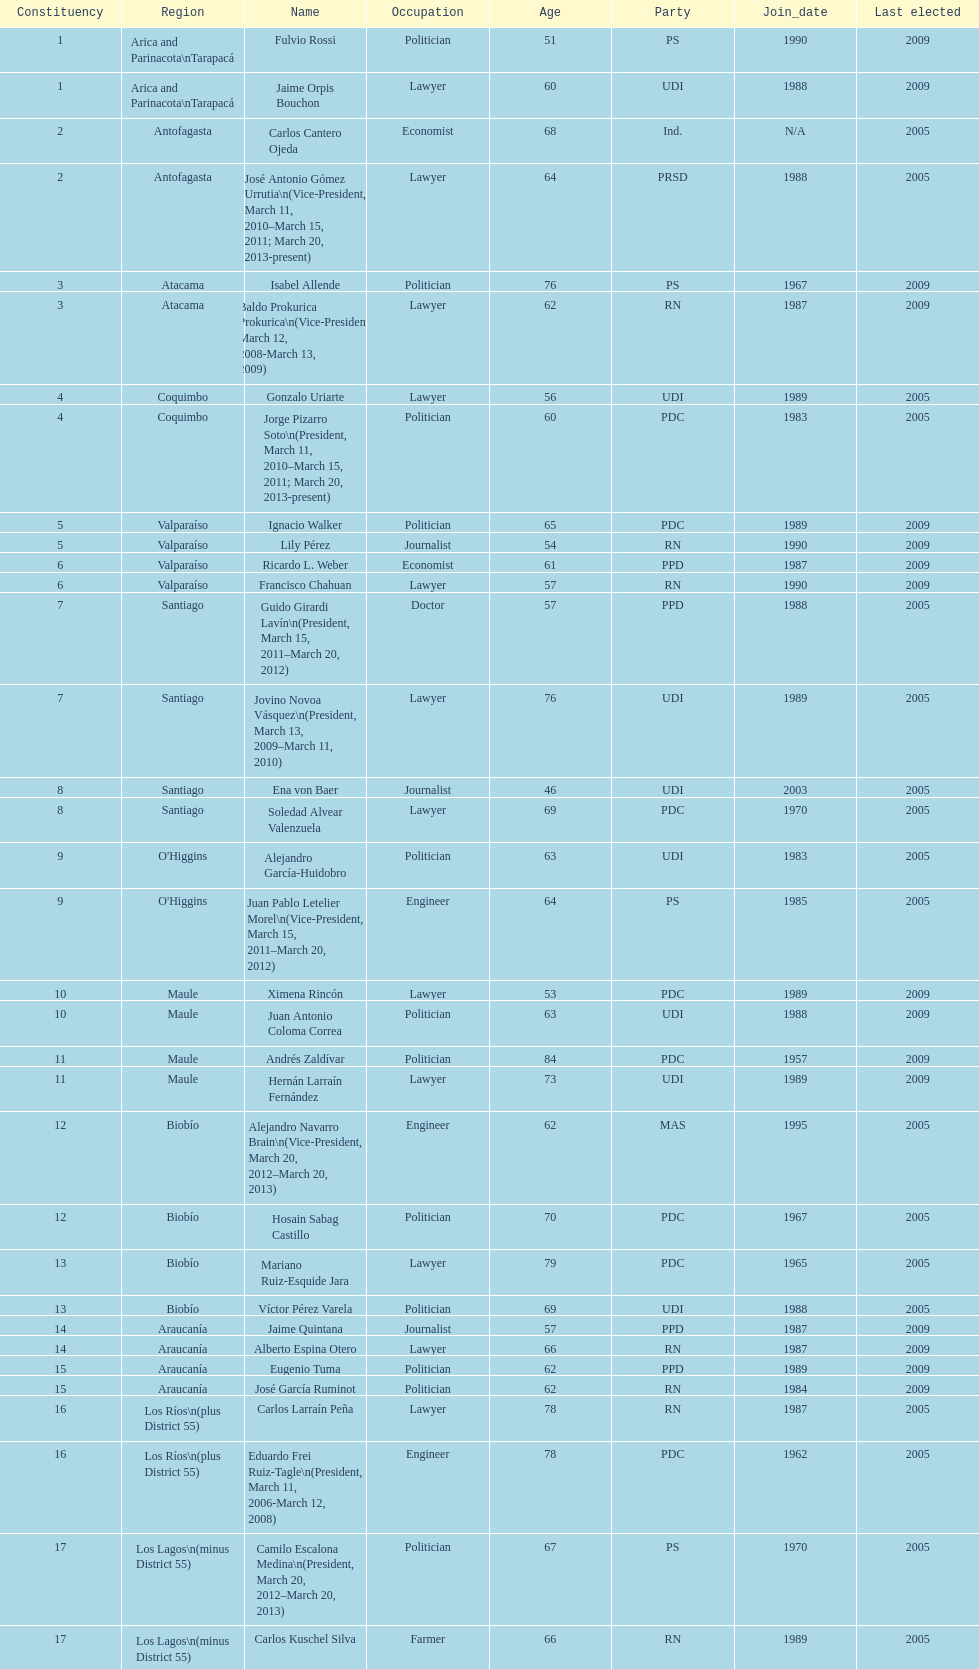When was antonio horvath kiss last elected? 2001. 